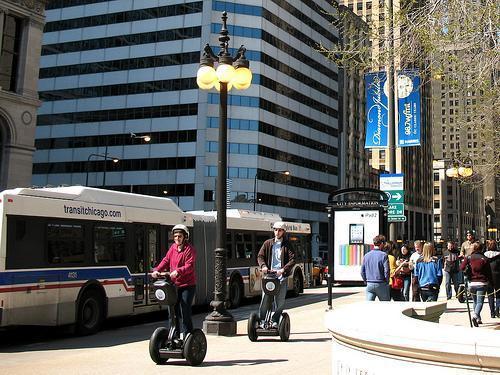How many scooters are there?
Give a very brief answer. 2. 